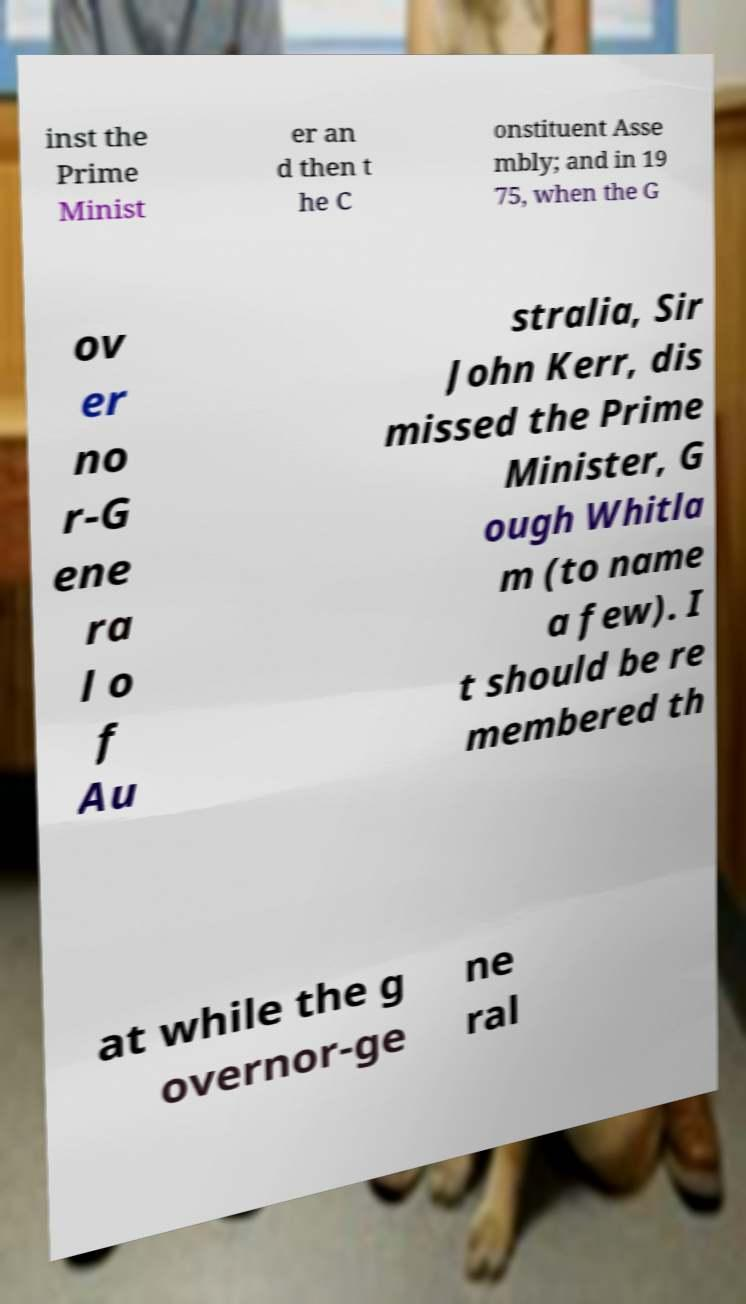Could you assist in decoding the text presented in this image and type it out clearly? inst the Prime Minist er an d then t he C onstituent Asse mbly; and in 19 75, when the G ov er no r-G ene ra l o f Au stralia, Sir John Kerr, dis missed the Prime Minister, G ough Whitla m (to name a few). I t should be re membered th at while the g overnor-ge ne ral 